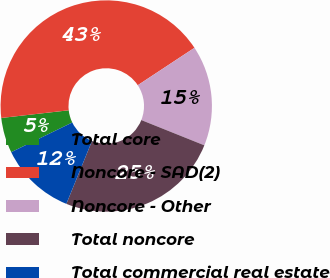<chart> <loc_0><loc_0><loc_500><loc_500><pie_chart><fcel>Total core<fcel>Noncore - SAD(2)<fcel>Noncore - Other<fcel>Total noncore<fcel>Total commercial real estate<nl><fcel>5.39%<fcel>42.52%<fcel>15.35%<fcel>25.09%<fcel>11.64%<nl></chart> 